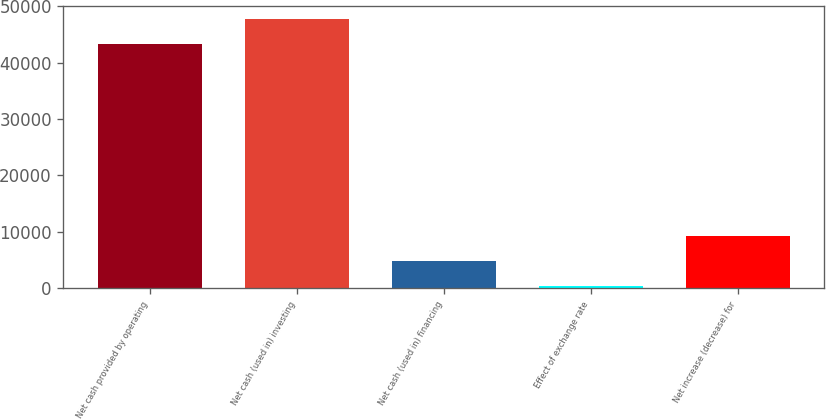Convert chart. <chart><loc_0><loc_0><loc_500><loc_500><bar_chart><fcel>Net cash provided by operating<fcel>Net cash (used in) investing<fcel>Net cash (used in) financing<fcel>Effect of exchange rate<fcel>Net increase (decrease) for<nl><fcel>43327<fcel>47693.7<fcel>4864.7<fcel>498<fcel>9231.4<nl></chart> 